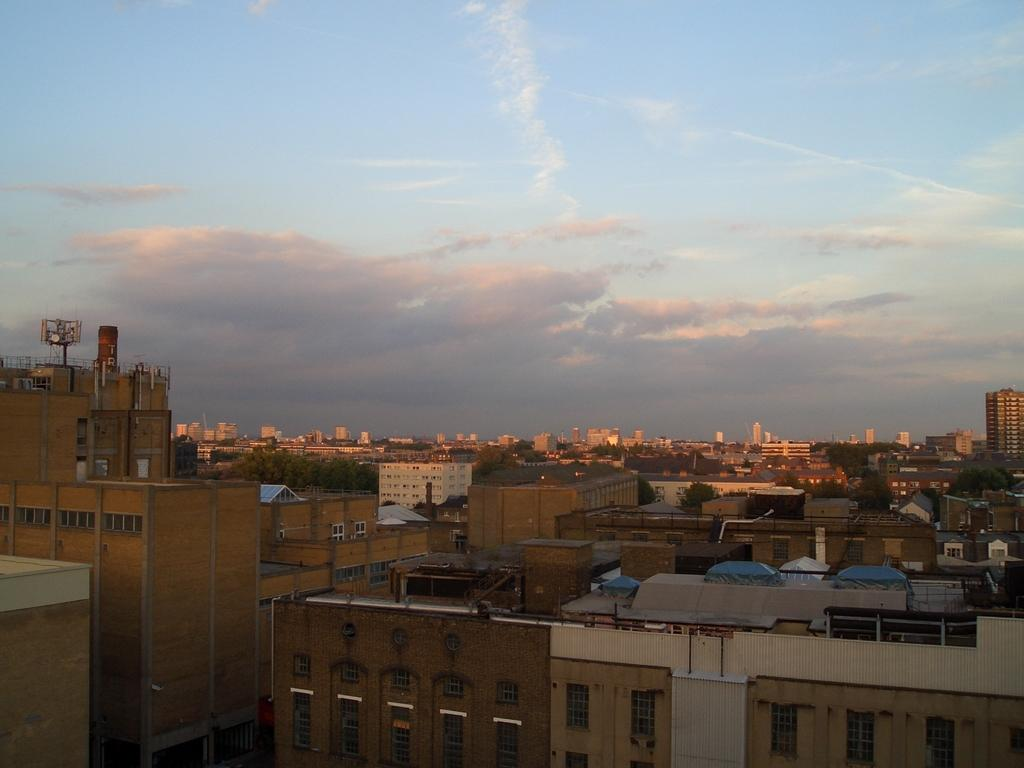What type of structures can be seen in the image? There are buildings in the image. What type of vegetation is present in the image? There are trees in the image. What can be seen in the sky in the image? There are clouds in the image. Where is the goat located in the image? There is no goat present in the image. What type of fruit is hanging from the trees in the image? There is no fruit mentioned in the image, and the type of trees is not specified. What tool is being used by someone in the image? There is no tool or person performing an action mentioned in the image. 